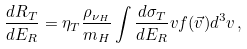<formula> <loc_0><loc_0><loc_500><loc_500>\frac { d R _ { T } } { d E _ { R } } = \eta _ { T } \frac { \rho _ { \nu _ { H } } } { m _ { H } } \int \frac { d \sigma _ { T } } { d E _ { R } } v f ( \vec { v } ) d ^ { 3 } v \, ,</formula> 